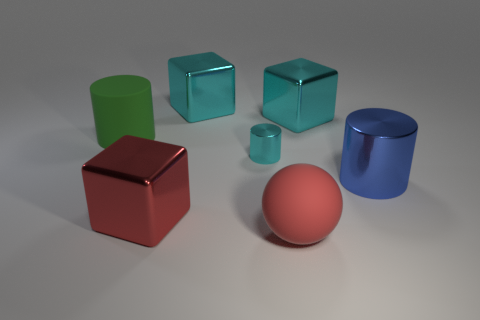Add 1 cyan cubes. How many objects exist? 8 Subtract all blocks. How many objects are left? 4 Add 1 large green cylinders. How many large green cylinders exist? 2 Subtract 0 green cubes. How many objects are left? 7 Subtract all small brown metal blocks. Subtract all cyan shiny things. How many objects are left? 4 Add 2 cyan metal cylinders. How many cyan metal cylinders are left? 3 